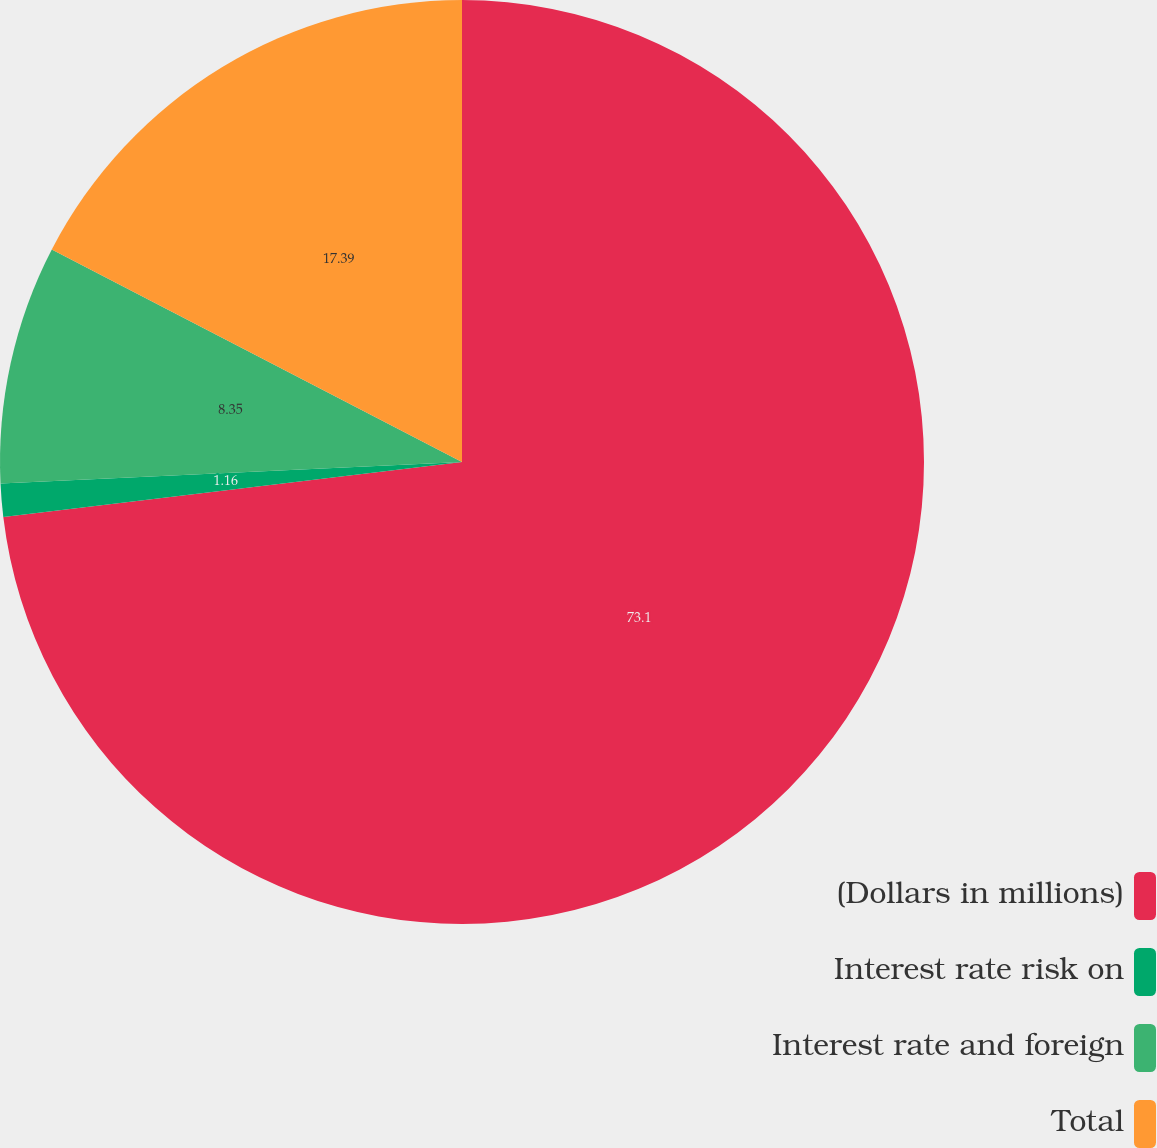<chart> <loc_0><loc_0><loc_500><loc_500><pie_chart><fcel>(Dollars in millions)<fcel>Interest rate risk on<fcel>Interest rate and foreign<fcel>Total<nl><fcel>73.09%<fcel>1.16%<fcel>8.35%<fcel>17.39%<nl></chart> 